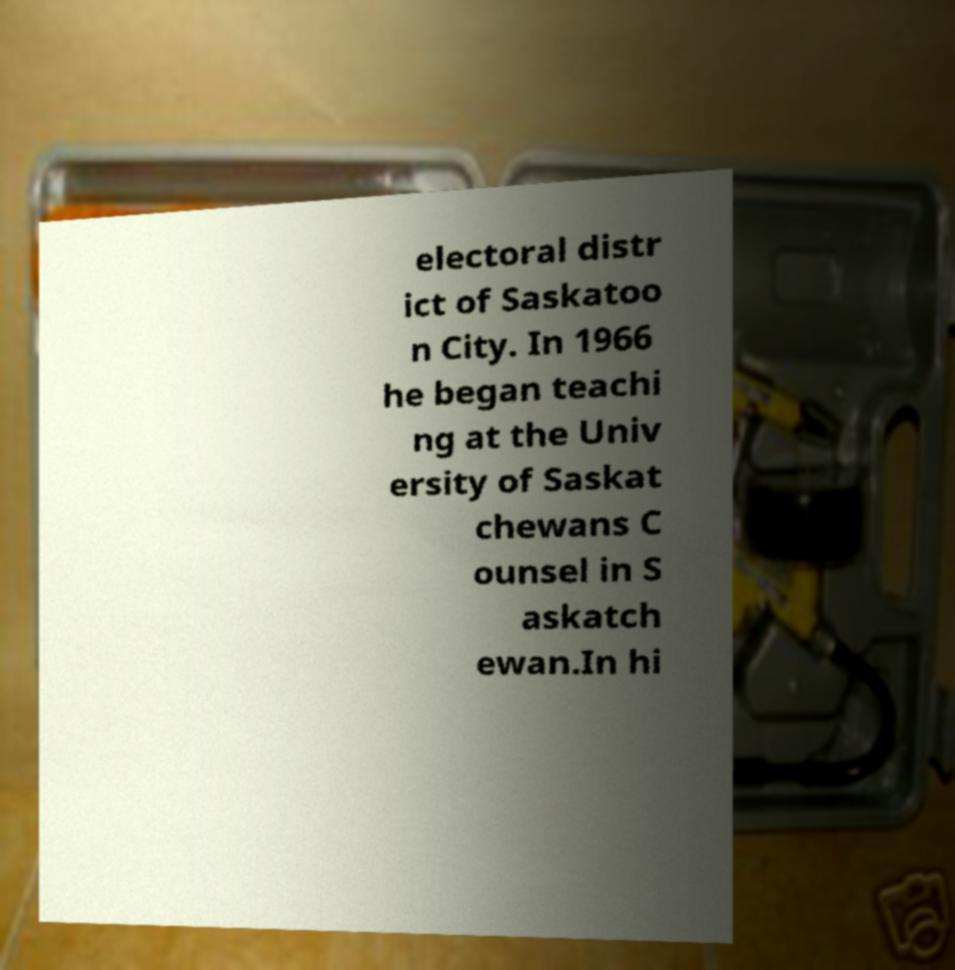For documentation purposes, I need the text within this image transcribed. Could you provide that? electoral distr ict of Saskatoo n City. In 1966 he began teachi ng at the Univ ersity of Saskat chewans C ounsel in S askatch ewan.In hi 